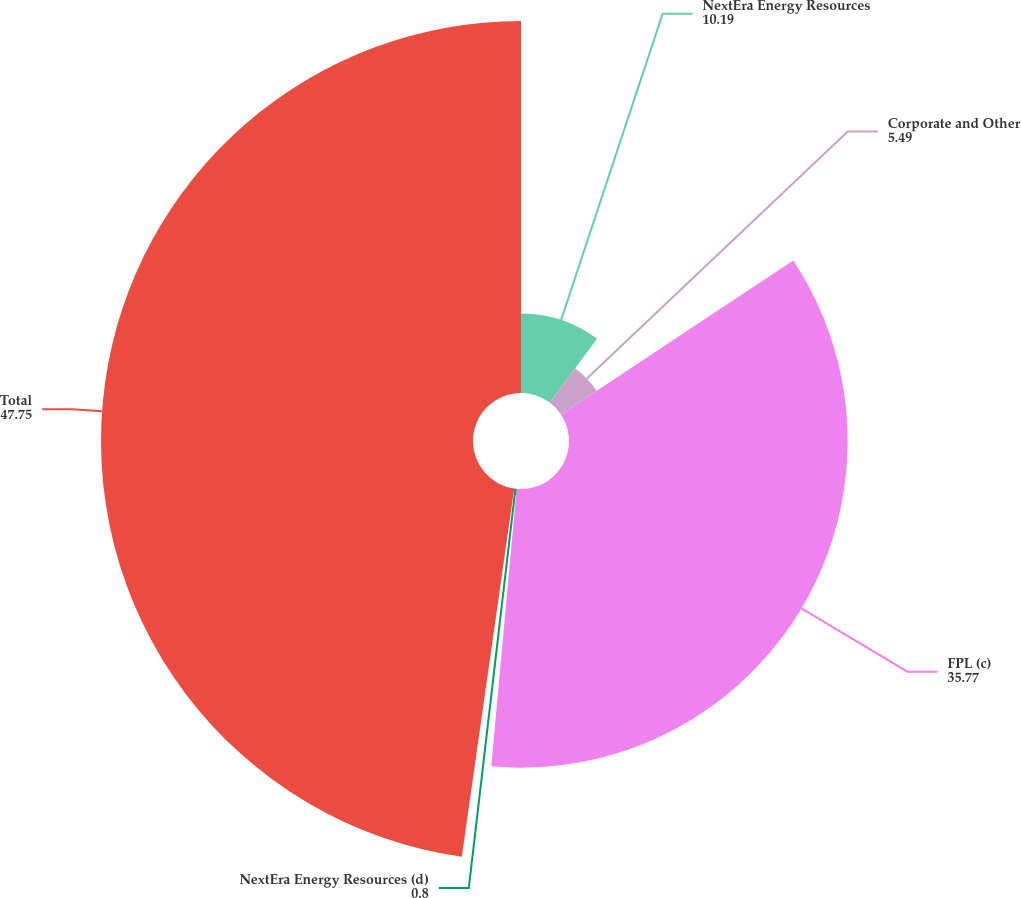Convert chart to OTSL. <chart><loc_0><loc_0><loc_500><loc_500><pie_chart><fcel>NextEra Energy Resources<fcel>Corporate and Other<fcel>FPL (c)<fcel>NextEra Energy Resources (d)<fcel>Total<nl><fcel>10.19%<fcel>5.49%<fcel>35.77%<fcel>0.8%<fcel>47.75%<nl></chart> 